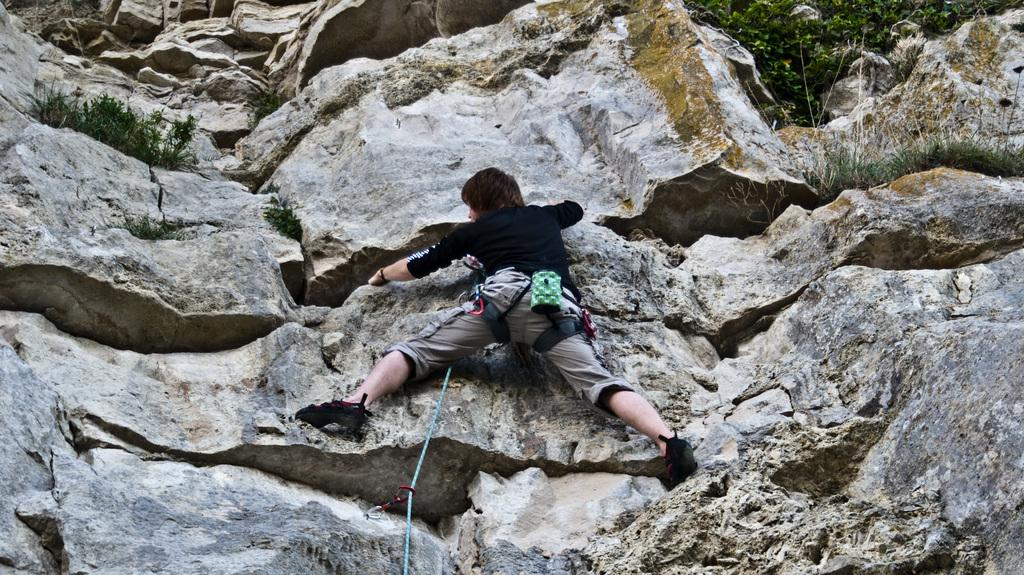What activity is the person in the image engaged in? The person in the image is doing rock climbing. What can be seen in the background of the image? There are plants and grass in the background of the image. What songs is the person singing while rock climbing in the image? There is no indication in the image that the person is singing any songs while rock climbing. 